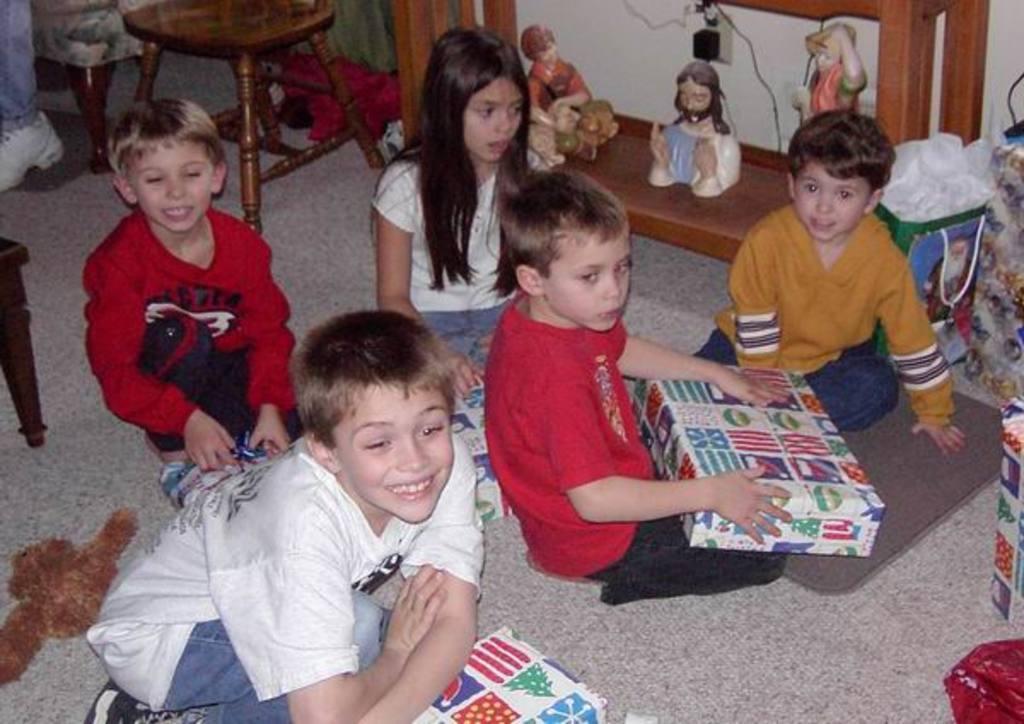Could you give a brief overview of what you see in this image? In this image we can see children on the floor, a child is holding a box, there are few object on the floor, there is a stool and few statues on the table. 